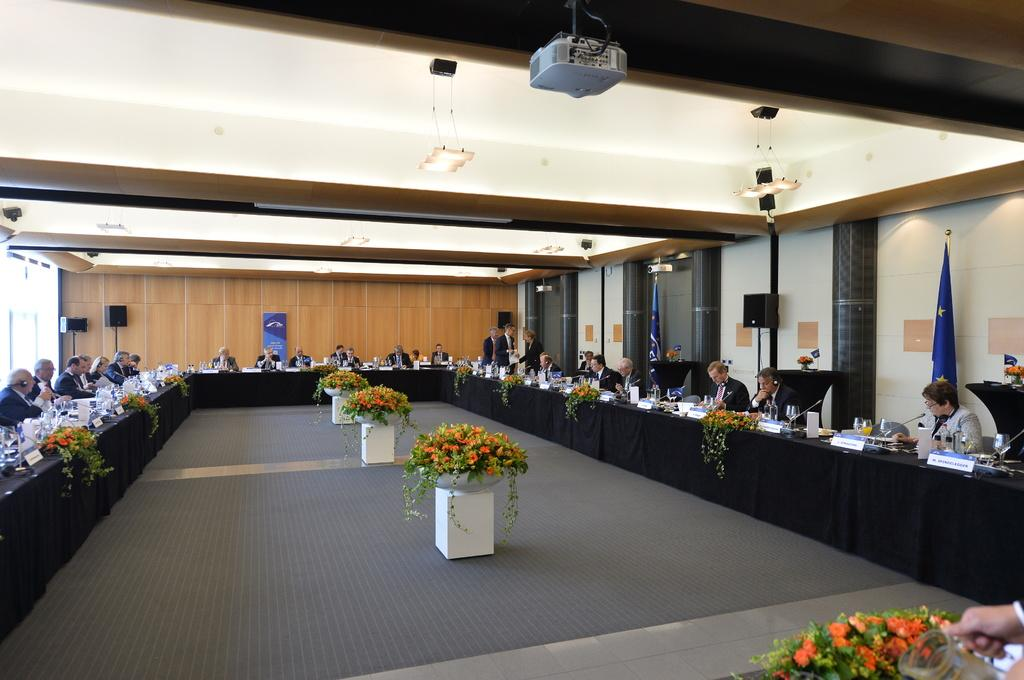What is happening in the image? There is a conference meeting taking place. What can be seen at the center of the image? There are flowers at the center of the image. What device is used for displaying information in the image? There is a projector at the top of the image. What items are located in the right corner of the image? There are two flags and a speaker in the right corner of the image. What parcel is being delivered during the conference meeting? There is no parcel being delivered during the conference meeting in the image. Can you tell me how many pockets are visible on the participants in the image? There is no information about pockets on the participants in the image. 